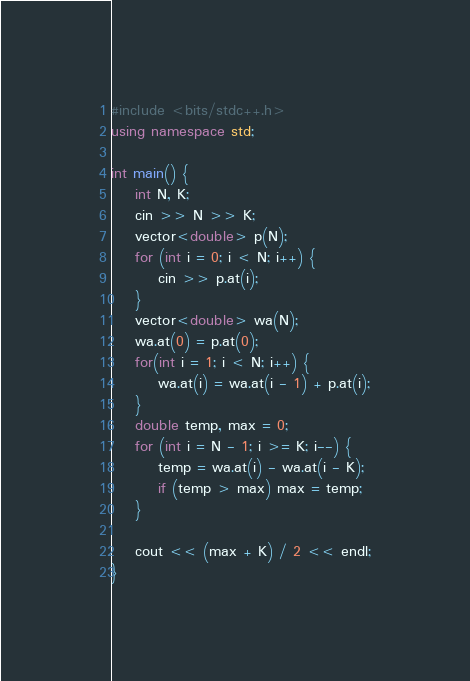<code> <loc_0><loc_0><loc_500><loc_500><_C++_>#include <bits/stdc++.h>
using namespace std;

int main() {
    int N, K;
    cin >> N >> K;
    vector<double> p(N);
    for (int i = 0; i < N; i++) {
        cin >> p.at(i);
    }
    vector<double> wa(N);
    wa.at(0) = p.at(0);
    for(int i = 1; i < N; i++) {
        wa.at(i) = wa.at(i - 1) + p.at(i);
    }
    double temp, max = 0;
    for (int i = N - 1; i >= K; i--) {
        temp = wa.at(i) - wa.at(i - K);
        if (temp > max) max = temp;
    }
    
    cout << (max + K) / 2 << endl;
}</code> 